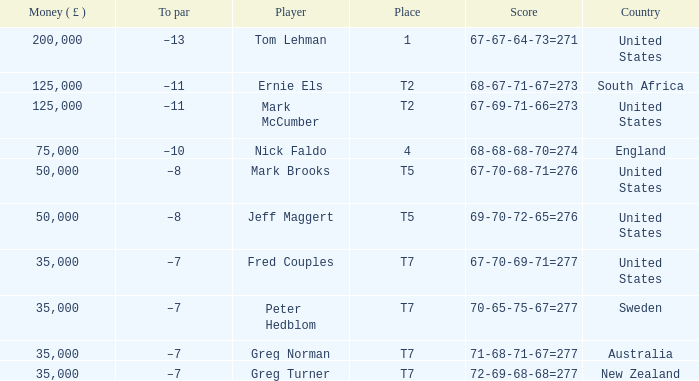What is To par, when Country is "United States", when Money ( £ ) is greater than 125,000, and when Score is "67-70-68-71=276"? None. 